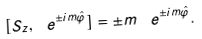<formula> <loc_0><loc_0><loc_500><loc_500>[ S _ { z } , \ e ^ { \pm i m \hat { \varphi } } ] = \pm m \, \ e ^ { \pm i m \hat { \varphi } } .</formula> 